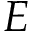<formula> <loc_0><loc_0><loc_500><loc_500>E</formula> 